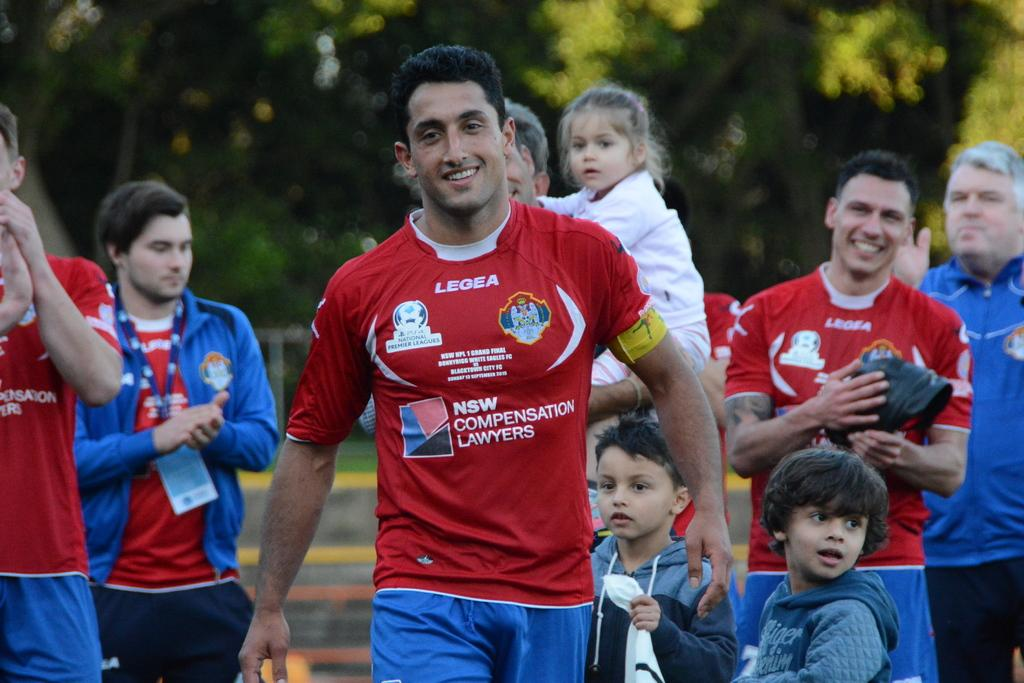Who or what is present in the image? There are people in the image. What can be observed about the background of the image? The background of the image is blurry. What type of natural elements can be seen in the background? There are trees visible in the background of the image. How many roses can be seen growing on the trees in the image? There are no roses visible in the image; only trees are present in the background. Can you describe the kittens playing in the foreground of the image? There are no kittens present in the image; it features people and a blurry background with trees. 